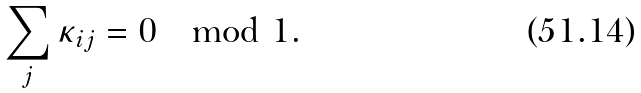<formula> <loc_0><loc_0><loc_500><loc_500>\sum _ { j } \kappa _ { i j } = 0 \mod 1 .</formula> 